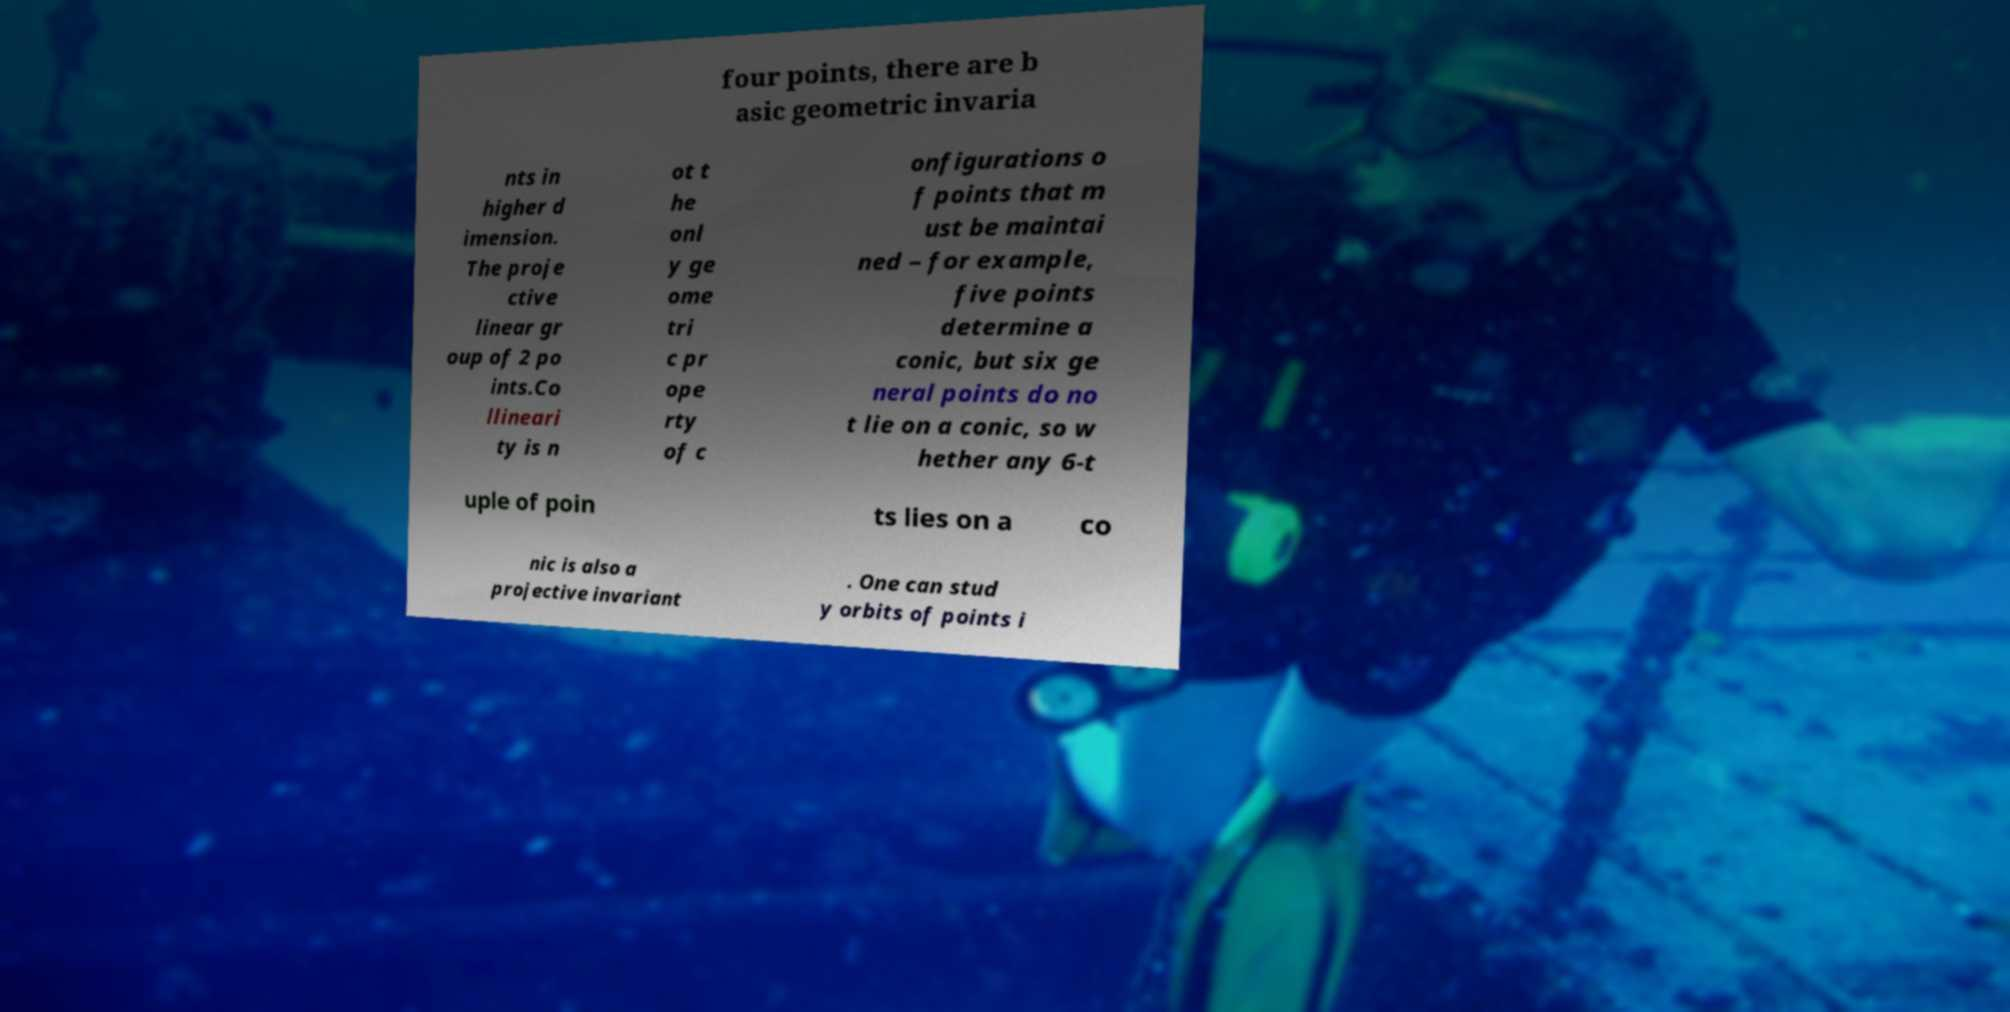Could you assist in decoding the text presented in this image and type it out clearly? four points, there are b asic geometric invaria nts in higher d imension. The proje ctive linear gr oup of 2 po ints.Co llineari ty is n ot t he onl y ge ome tri c pr ope rty of c onfigurations o f points that m ust be maintai ned – for example, five points determine a conic, but six ge neral points do no t lie on a conic, so w hether any 6-t uple of poin ts lies on a co nic is also a projective invariant . One can stud y orbits of points i 